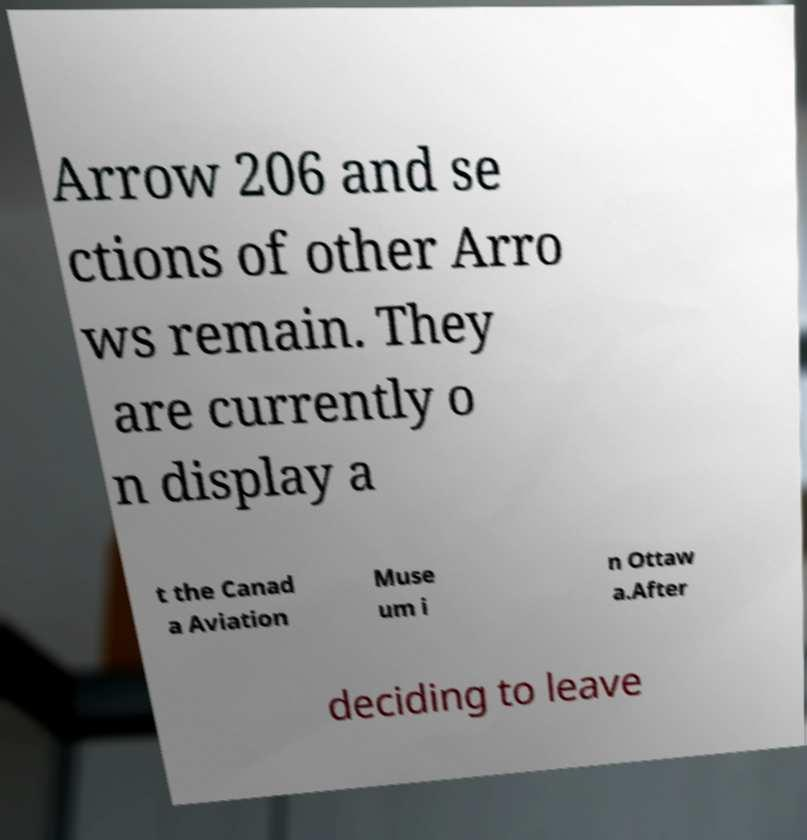There's text embedded in this image that I need extracted. Can you transcribe it verbatim? Arrow 206 and se ctions of other Arro ws remain. They are currently o n display a t the Canad a Aviation Muse um i n Ottaw a.After deciding to leave 